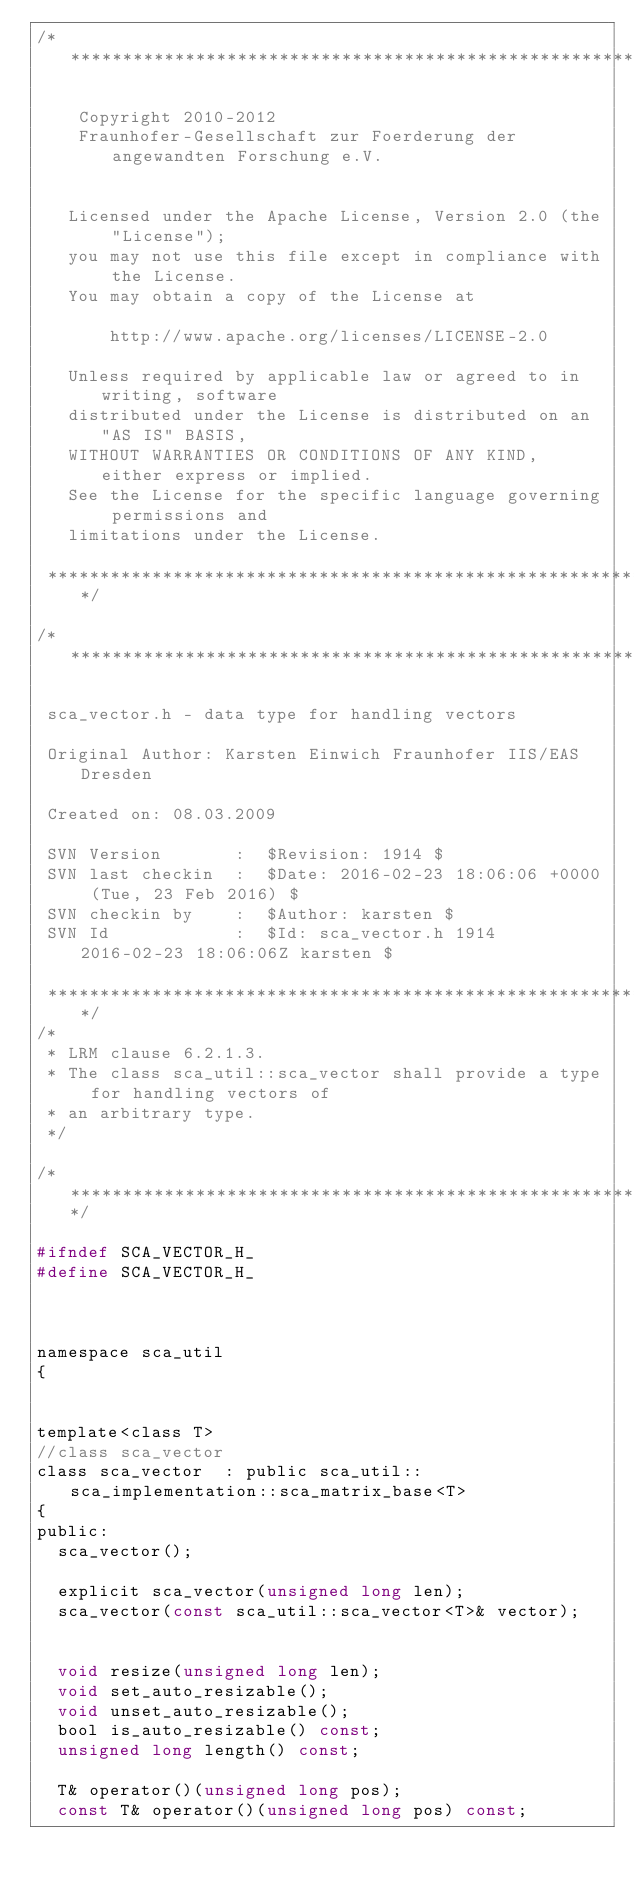Convert code to text. <code><loc_0><loc_0><loc_500><loc_500><_C_>/*****************************************************************************

    Copyright 2010-2012
    Fraunhofer-Gesellschaft zur Foerderung der angewandten Forschung e.V.


   Licensed under the Apache License, Version 2.0 (the "License");
   you may not use this file except in compliance with the License.
   You may obtain a copy of the License at

       http://www.apache.org/licenses/LICENSE-2.0

   Unless required by applicable law or agreed to in writing, software
   distributed under the License is distributed on an "AS IS" BASIS,
   WITHOUT WARRANTIES OR CONDITIONS OF ANY KIND, either express or implied.
   See the License for the specific language governing permissions and
   limitations under the License.

 *****************************************************************************/

/*****************************************************************************

 sca_vector.h - data type for handling vectors

 Original Author: Karsten Einwich Fraunhofer IIS/EAS Dresden

 Created on: 08.03.2009

 SVN Version       :  $Revision: 1914 $
 SVN last checkin  :  $Date: 2016-02-23 18:06:06 +0000 (Tue, 23 Feb 2016) $
 SVN checkin by    :  $Author: karsten $
 SVN Id            :  $Id: sca_vector.h 1914 2016-02-23 18:06:06Z karsten $

 *****************************************************************************/
/*
 * LRM clause 6.2.1.3.
 * The class sca_util::sca_vector shall provide a type for handling vectors of
 * an arbitrary type.
 */

/*****************************************************************************/

#ifndef SCA_VECTOR_H_
#define SCA_VECTOR_H_



namespace sca_util
{


template<class T>
//class sca_vector
class sca_vector  : public sca_util::sca_implementation::sca_matrix_base<T>
{
public:
	sca_vector();

	explicit sca_vector(unsigned long len);
	sca_vector(const sca_util::sca_vector<T>& vector);


	void resize(unsigned long len);
	void set_auto_resizable();
	void unset_auto_resizable();
	bool is_auto_resizable() const;
	unsigned long length() const;

	T& operator()(unsigned long pos);
	const T& operator()(unsigned long pos) const;
</code> 